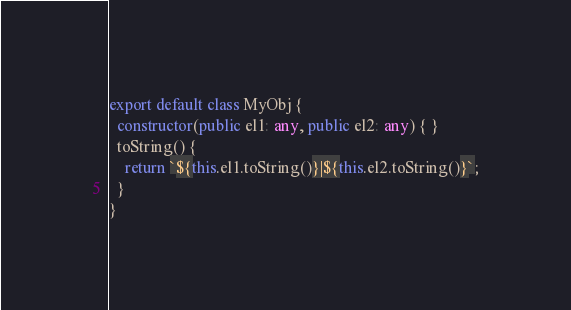<code> <loc_0><loc_0><loc_500><loc_500><_TypeScript_>export default class MyObj {
  constructor(public el1: any, public el2: any) { }
  toString() {
    return `${this.el1.toString()}|${this.el2.toString()}`;
  }
}

</code> 